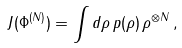Convert formula to latex. <formula><loc_0><loc_0><loc_500><loc_500>J ( \Phi ^ { ( N ) } ) = \int d \rho \, p ( \rho ) \, \rho ^ { \otimes N } \, ,</formula> 